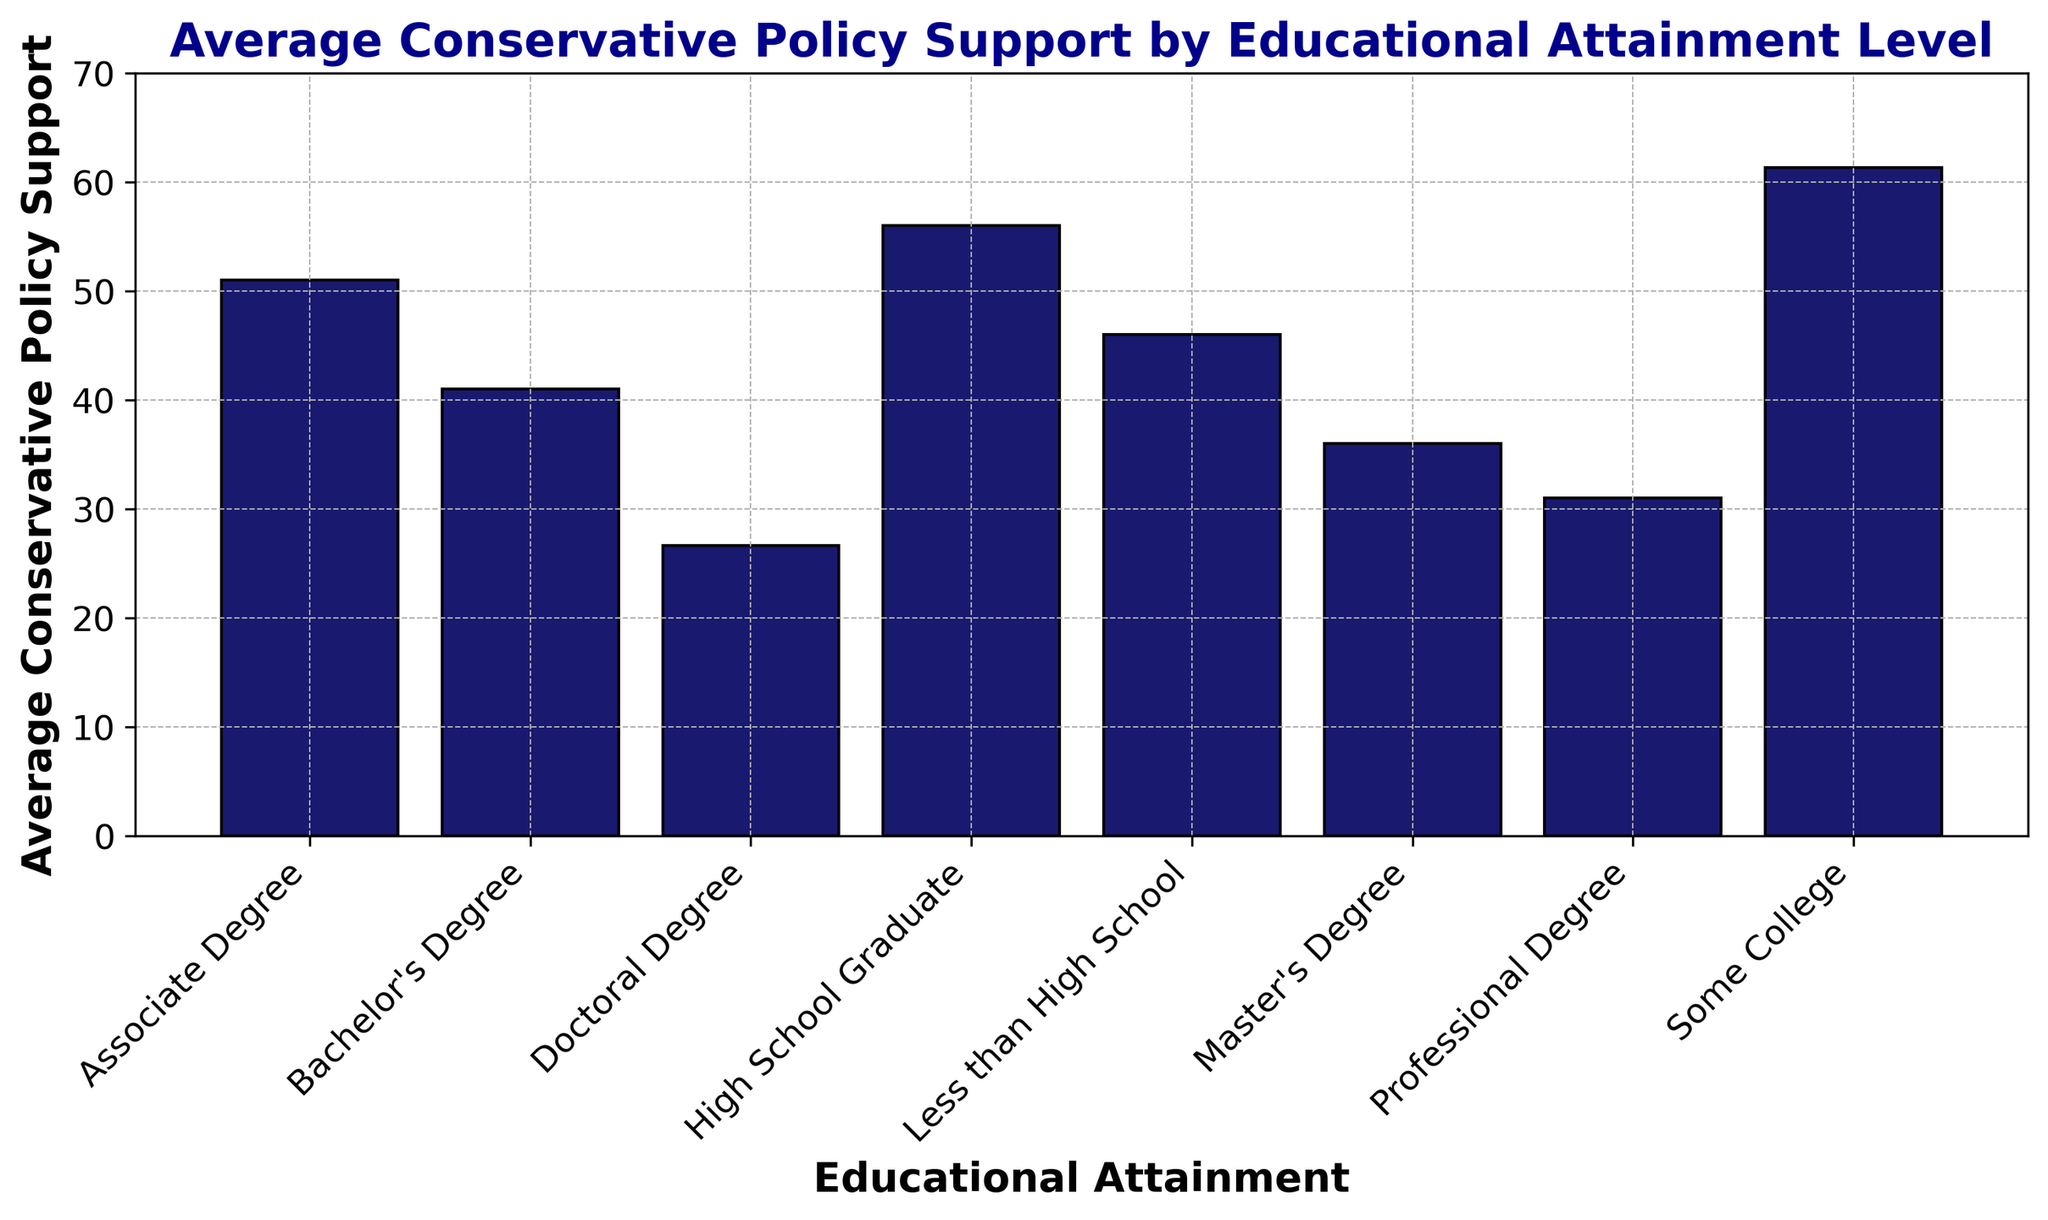What is the overall trend in conservative policy support as the level of educational attainment increases? The overall trend shows that as the educational attainment level increases, the average conservative policy support tends to decrease. This is evident from the bar heights in the histogram that show a decrease from 'Less than High School' to 'Doctoral Degree'.
Answer: Conservative policy support decreases with higher educational attainment Which educational attainment group has the highest average conservative policy support? By observing the heights of the bars, the group 'Some College' has the highest average conservative policy support, indicated by the tallest bar.
Answer: Some College Is there a significant drop in conservative policy support between any two consecutive educational attainment levels? The most significant drop is between 'Some College' and 'Associate Degree'. While 'Some College' averages around 61, 'Associate Degree' averages around 51. The drop is approximately 10 points.
Answer: Between 'Some College' and 'Associate Degree' What is the average difference in conservative policy support between 'High School Graduate' and 'Doctoral Degree'? "High School Graduate" has an average support of about 56, while "Doctoral Degree" has about 26. The difference is 56 - 26 = 30.
Answer: 30 Which two educational groups have conservative policy support closest to each other? 'Master's Degree' and 'Professional Degree' are closest, with average supports of around 36 and 31 respectively, making a difference of about 5.
Answer: Master's Degree and Professional Degree Based on the histogram, which educational attainment group has a support level that is almost halfway between the lowest and highest values? The lowest value is 'Doctoral Degree' (25) and the highest is 'Some College' (61). The halfway point is (61 + 25) / 2 = 43. Around this range is 'Bachelor’s Degree' with an average support of 40.
Answer: Bachelor’s Degree How does the support for conservative policy among those with a 'Professional Degree' compare to those with a 'High School Graduate' education? 'Professional Degree' averages around 31, while 'High School Graduate' averages around 56. Therefore, support in 'High School Graduate' is significantly higher.
Answer: High School Graduate has higher support Among 'Associate Degree', 'Master’s Degree', and 'Professional Degree', which has the lowest conservative policy support? By comparing the bar heights, 'Professional Degree' shows the lowest conservative policy support among the three groups.
Answer: Professional Degree 